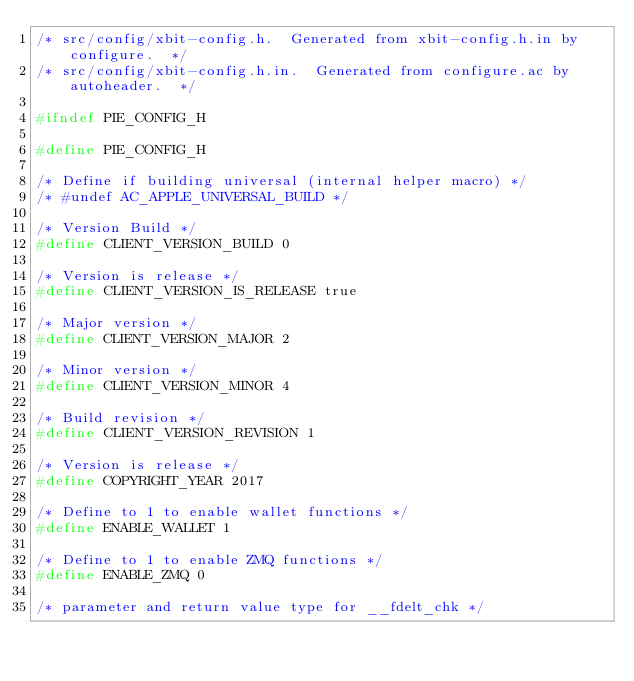Convert code to text. <code><loc_0><loc_0><loc_500><loc_500><_C_>/* src/config/xbit-config.h.  Generated from xbit-config.h.in by configure.  */
/* src/config/xbit-config.h.in.  Generated from configure.ac by autoheader.  */

#ifndef PIE_CONFIG_H

#define PIE_CONFIG_H

/* Define if building universal (internal helper macro) */
/* #undef AC_APPLE_UNIVERSAL_BUILD */

/* Version Build */
#define CLIENT_VERSION_BUILD 0

/* Version is release */
#define CLIENT_VERSION_IS_RELEASE true

/* Major version */
#define CLIENT_VERSION_MAJOR 2

/* Minor version */
#define CLIENT_VERSION_MINOR 4

/* Build revision */
#define CLIENT_VERSION_REVISION 1

/* Version is release */
#define COPYRIGHT_YEAR 2017

/* Define to 1 to enable wallet functions */
#define ENABLE_WALLET 1

/* Define to 1 to enable ZMQ functions */
#define ENABLE_ZMQ 0

/* parameter and return value type for __fdelt_chk */</code> 